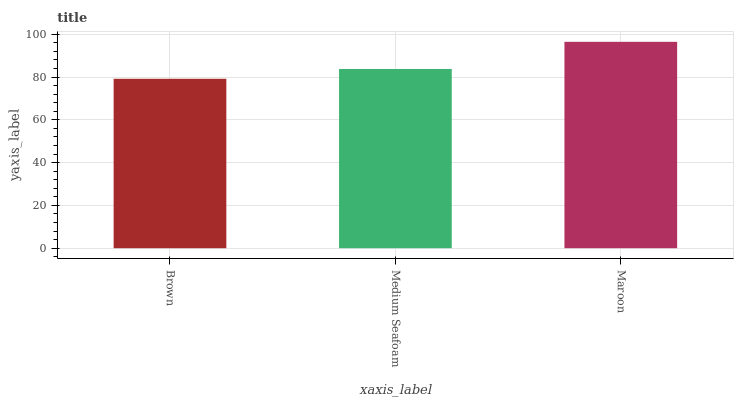Is Brown the minimum?
Answer yes or no. Yes. Is Maroon the maximum?
Answer yes or no. Yes. Is Medium Seafoam the minimum?
Answer yes or no. No. Is Medium Seafoam the maximum?
Answer yes or no. No. Is Medium Seafoam greater than Brown?
Answer yes or no. Yes. Is Brown less than Medium Seafoam?
Answer yes or no. Yes. Is Brown greater than Medium Seafoam?
Answer yes or no. No. Is Medium Seafoam less than Brown?
Answer yes or no. No. Is Medium Seafoam the high median?
Answer yes or no. Yes. Is Medium Seafoam the low median?
Answer yes or no. Yes. Is Brown the high median?
Answer yes or no. No. Is Brown the low median?
Answer yes or no. No. 